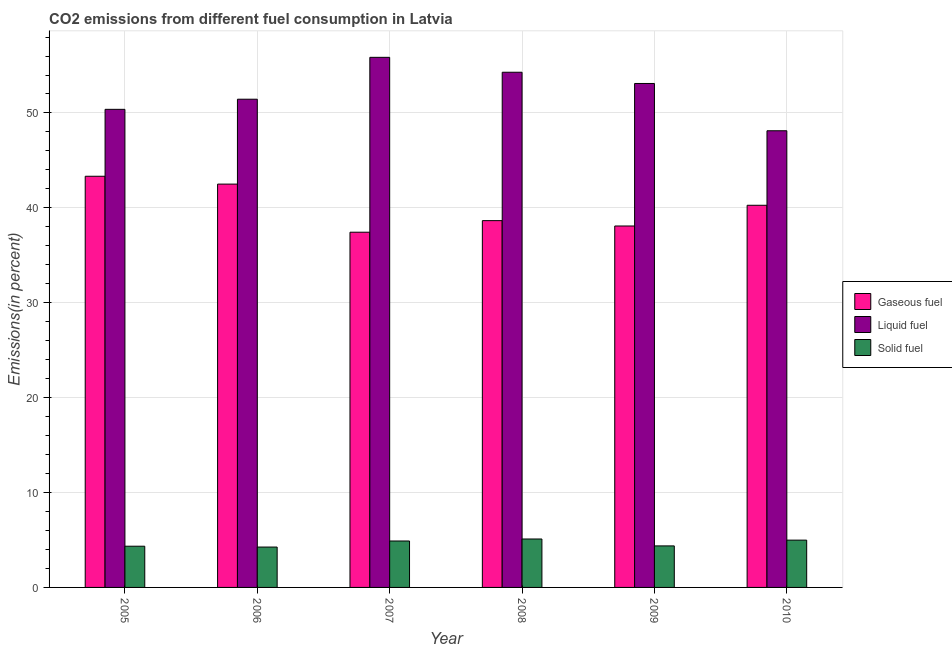How many bars are there on the 5th tick from the left?
Provide a succinct answer. 3. How many bars are there on the 4th tick from the right?
Offer a very short reply. 3. What is the percentage of gaseous fuel emission in 2010?
Keep it short and to the point. 40.27. Across all years, what is the maximum percentage of gaseous fuel emission?
Offer a very short reply. 43.33. Across all years, what is the minimum percentage of solid fuel emission?
Keep it short and to the point. 4.26. In which year was the percentage of gaseous fuel emission maximum?
Make the answer very short. 2005. In which year was the percentage of liquid fuel emission minimum?
Give a very brief answer. 2010. What is the total percentage of solid fuel emission in the graph?
Provide a short and direct response. 27.96. What is the difference between the percentage of gaseous fuel emission in 2007 and that in 2010?
Your answer should be compact. -2.84. What is the difference between the percentage of liquid fuel emission in 2007 and the percentage of gaseous fuel emission in 2005?
Your response must be concise. 5.48. What is the average percentage of gaseous fuel emission per year?
Keep it short and to the point. 40.05. In the year 2008, what is the difference between the percentage of solid fuel emission and percentage of liquid fuel emission?
Provide a short and direct response. 0. In how many years, is the percentage of solid fuel emission greater than 50 %?
Your answer should be compact. 0. What is the ratio of the percentage of gaseous fuel emission in 2005 to that in 2009?
Keep it short and to the point. 1.14. Is the difference between the percentage of solid fuel emission in 2006 and 2009 greater than the difference between the percentage of gaseous fuel emission in 2006 and 2009?
Your response must be concise. No. What is the difference between the highest and the second highest percentage of liquid fuel emission?
Give a very brief answer. 1.57. What is the difference between the highest and the lowest percentage of solid fuel emission?
Your answer should be very brief. 0.85. In how many years, is the percentage of gaseous fuel emission greater than the average percentage of gaseous fuel emission taken over all years?
Provide a succinct answer. 3. Is the sum of the percentage of gaseous fuel emission in 2005 and 2009 greater than the maximum percentage of solid fuel emission across all years?
Give a very brief answer. Yes. What does the 3rd bar from the left in 2008 represents?
Your answer should be compact. Solid fuel. What does the 1st bar from the right in 2008 represents?
Make the answer very short. Solid fuel. Is it the case that in every year, the sum of the percentage of gaseous fuel emission and percentage of liquid fuel emission is greater than the percentage of solid fuel emission?
Provide a succinct answer. Yes. Are all the bars in the graph horizontal?
Your answer should be very brief. No. How many years are there in the graph?
Your answer should be very brief. 6. Are the values on the major ticks of Y-axis written in scientific E-notation?
Your answer should be very brief. No. Does the graph contain grids?
Keep it short and to the point. Yes. Where does the legend appear in the graph?
Provide a short and direct response. Center right. How many legend labels are there?
Offer a very short reply. 3. What is the title of the graph?
Give a very brief answer. CO2 emissions from different fuel consumption in Latvia. What is the label or title of the Y-axis?
Offer a terse response. Emissions(in percent). What is the Emissions(in percent) in Gaseous fuel in 2005?
Keep it short and to the point. 43.33. What is the Emissions(in percent) in Liquid fuel in 2005?
Offer a terse response. 50.38. What is the Emissions(in percent) of Solid fuel in 2005?
Keep it short and to the point. 4.34. What is the Emissions(in percent) of Gaseous fuel in 2006?
Offer a terse response. 42.5. What is the Emissions(in percent) of Liquid fuel in 2006?
Your response must be concise. 51.45. What is the Emissions(in percent) of Solid fuel in 2006?
Make the answer very short. 4.26. What is the Emissions(in percent) of Gaseous fuel in 2007?
Ensure brevity in your answer.  37.43. What is the Emissions(in percent) of Liquid fuel in 2007?
Ensure brevity in your answer.  55.86. What is the Emissions(in percent) in Solid fuel in 2007?
Your response must be concise. 4.89. What is the Emissions(in percent) of Gaseous fuel in 2008?
Your answer should be very brief. 38.65. What is the Emissions(in percent) in Liquid fuel in 2008?
Give a very brief answer. 54.29. What is the Emissions(in percent) in Solid fuel in 2008?
Make the answer very short. 5.1. What is the Emissions(in percent) in Gaseous fuel in 2009?
Offer a very short reply. 38.09. What is the Emissions(in percent) of Liquid fuel in 2009?
Make the answer very short. 53.11. What is the Emissions(in percent) in Solid fuel in 2009?
Your answer should be compact. 4.38. What is the Emissions(in percent) of Gaseous fuel in 2010?
Provide a succinct answer. 40.27. What is the Emissions(in percent) in Liquid fuel in 2010?
Provide a succinct answer. 48.13. What is the Emissions(in percent) in Solid fuel in 2010?
Provide a short and direct response. 4.98. Across all years, what is the maximum Emissions(in percent) in Gaseous fuel?
Keep it short and to the point. 43.33. Across all years, what is the maximum Emissions(in percent) in Liquid fuel?
Your answer should be compact. 55.86. Across all years, what is the maximum Emissions(in percent) in Solid fuel?
Provide a short and direct response. 5.1. Across all years, what is the minimum Emissions(in percent) of Gaseous fuel?
Keep it short and to the point. 37.43. Across all years, what is the minimum Emissions(in percent) of Liquid fuel?
Offer a very short reply. 48.13. Across all years, what is the minimum Emissions(in percent) in Solid fuel?
Your answer should be compact. 4.26. What is the total Emissions(in percent) in Gaseous fuel in the graph?
Provide a succinct answer. 240.29. What is the total Emissions(in percent) in Liquid fuel in the graph?
Make the answer very short. 313.22. What is the total Emissions(in percent) of Solid fuel in the graph?
Your answer should be very brief. 27.96. What is the difference between the Emissions(in percent) of Gaseous fuel in 2005 and that in 2006?
Offer a terse response. 0.83. What is the difference between the Emissions(in percent) in Liquid fuel in 2005 and that in 2006?
Your response must be concise. -1.07. What is the difference between the Emissions(in percent) of Solid fuel in 2005 and that in 2006?
Offer a terse response. 0.09. What is the difference between the Emissions(in percent) in Gaseous fuel in 2005 and that in 2007?
Offer a very short reply. 5.9. What is the difference between the Emissions(in percent) of Liquid fuel in 2005 and that in 2007?
Provide a succinct answer. -5.48. What is the difference between the Emissions(in percent) of Solid fuel in 2005 and that in 2007?
Offer a very short reply. -0.55. What is the difference between the Emissions(in percent) of Gaseous fuel in 2005 and that in 2008?
Keep it short and to the point. 4.68. What is the difference between the Emissions(in percent) in Liquid fuel in 2005 and that in 2008?
Ensure brevity in your answer.  -3.91. What is the difference between the Emissions(in percent) in Solid fuel in 2005 and that in 2008?
Keep it short and to the point. -0.76. What is the difference between the Emissions(in percent) of Gaseous fuel in 2005 and that in 2009?
Keep it short and to the point. 5.24. What is the difference between the Emissions(in percent) in Liquid fuel in 2005 and that in 2009?
Ensure brevity in your answer.  -2.72. What is the difference between the Emissions(in percent) in Solid fuel in 2005 and that in 2009?
Provide a short and direct response. -0.03. What is the difference between the Emissions(in percent) in Gaseous fuel in 2005 and that in 2010?
Provide a short and direct response. 3.06. What is the difference between the Emissions(in percent) in Liquid fuel in 2005 and that in 2010?
Ensure brevity in your answer.  2.26. What is the difference between the Emissions(in percent) of Solid fuel in 2005 and that in 2010?
Your answer should be very brief. -0.64. What is the difference between the Emissions(in percent) in Gaseous fuel in 2006 and that in 2007?
Make the answer very short. 5.07. What is the difference between the Emissions(in percent) in Liquid fuel in 2006 and that in 2007?
Your response must be concise. -4.41. What is the difference between the Emissions(in percent) of Solid fuel in 2006 and that in 2007?
Ensure brevity in your answer.  -0.64. What is the difference between the Emissions(in percent) of Gaseous fuel in 2006 and that in 2008?
Make the answer very short. 3.85. What is the difference between the Emissions(in percent) in Liquid fuel in 2006 and that in 2008?
Offer a terse response. -2.84. What is the difference between the Emissions(in percent) of Solid fuel in 2006 and that in 2008?
Your response must be concise. -0.85. What is the difference between the Emissions(in percent) in Gaseous fuel in 2006 and that in 2009?
Provide a short and direct response. 4.41. What is the difference between the Emissions(in percent) in Liquid fuel in 2006 and that in 2009?
Offer a very short reply. -1.66. What is the difference between the Emissions(in percent) in Solid fuel in 2006 and that in 2009?
Your answer should be very brief. -0.12. What is the difference between the Emissions(in percent) in Gaseous fuel in 2006 and that in 2010?
Give a very brief answer. 2.23. What is the difference between the Emissions(in percent) of Liquid fuel in 2006 and that in 2010?
Provide a short and direct response. 3.33. What is the difference between the Emissions(in percent) of Solid fuel in 2006 and that in 2010?
Ensure brevity in your answer.  -0.73. What is the difference between the Emissions(in percent) of Gaseous fuel in 2007 and that in 2008?
Provide a succinct answer. -1.22. What is the difference between the Emissions(in percent) of Liquid fuel in 2007 and that in 2008?
Your answer should be very brief. 1.57. What is the difference between the Emissions(in percent) in Solid fuel in 2007 and that in 2008?
Your answer should be very brief. -0.21. What is the difference between the Emissions(in percent) of Gaseous fuel in 2007 and that in 2009?
Make the answer very short. -0.66. What is the difference between the Emissions(in percent) in Liquid fuel in 2007 and that in 2009?
Offer a very short reply. 2.76. What is the difference between the Emissions(in percent) of Solid fuel in 2007 and that in 2009?
Give a very brief answer. 0.52. What is the difference between the Emissions(in percent) of Gaseous fuel in 2007 and that in 2010?
Make the answer very short. -2.84. What is the difference between the Emissions(in percent) in Liquid fuel in 2007 and that in 2010?
Provide a succinct answer. 7.74. What is the difference between the Emissions(in percent) in Solid fuel in 2007 and that in 2010?
Your answer should be very brief. -0.09. What is the difference between the Emissions(in percent) in Gaseous fuel in 2008 and that in 2009?
Provide a succinct answer. 0.56. What is the difference between the Emissions(in percent) of Liquid fuel in 2008 and that in 2009?
Ensure brevity in your answer.  1.18. What is the difference between the Emissions(in percent) in Solid fuel in 2008 and that in 2009?
Provide a short and direct response. 0.73. What is the difference between the Emissions(in percent) in Gaseous fuel in 2008 and that in 2010?
Ensure brevity in your answer.  -1.62. What is the difference between the Emissions(in percent) in Liquid fuel in 2008 and that in 2010?
Provide a short and direct response. 6.17. What is the difference between the Emissions(in percent) in Solid fuel in 2008 and that in 2010?
Ensure brevity in your answer.  0.12. What is the difference between the Emissions(in percent) of Gaseous fuel in 2009 and that in 2010?
Keep it short and to the point. -2.18. What is the difference between the Emissions(in percent) of Liquid fuel in 2009 and that in 2010?
Give a very brief answer. 4.98. What is the difference between the Emissions(in percent) in Solid fuel in 2009 and that in 2010?
Provide a short and direct response. -0.61. What is the difference between the Emissions(in percent) in Gaseous fuel in 2005 and the Emissions(in percent) in Liquid fuel in 2006?
Ensure brevity in your answer.  -8.12. What is the difference between the Emissions(in percent) of Gaseous fuel in 2005 and the Emissions(in percent) of Solid fuel in 2006?
Your response must be concise. 39.08. What is the difference between the Emissions(in percent) in Liquid fuel in 2005 and the Emissions(in percent) in Solid fuel in 2006?
Offer a very short reply. 46.13. What is the difference between the Emissions(in percent) in Gaseous fuel in 2005 and the Emissions(in percent) in Liquid fuel in 2007?
Offer a very short reply. -12.53. What is the difference between the Emissions(in percent) in Gaseous fuel in 2005 and the Emissions(in percent) in Solid fuel in 2007?
Make the answer very short. 38.44. What is the difference between the Emissions(in percent) in Liquid fuel in 2005 and the Emissions(in percent) in Solid fuel in 2007?
Provide a succinct answer. 45.49. What is the difference between the Emissions(in percent) in Gaseous fuel in 2005 and the Emissions(in percent) in Liquid fuel in 2008?
Offer a terse response. -10.96. What is the difference between the Emissions(in percent) in Gaseous fuel in 2005 and the Emissions(in percent) in Solid fuel in 2008?
Offer a terse response. 38.23. What is the difference between the Emissions(in percent) of Liquid fuel in 2005 and the Emissions(in percent) of Solid fuel in 2008?
Your response must be concise. 45.28. What is the difference between the Emissions(in percent) in Gaseous fuel in 2005 and the Emissions(in percent) in Liquid fuel in 2009?
Your answer should be very brief. -9.78. What is the difference between the Emissions(in percent) of Gaseous fuel in 2005 and the Emissions(in percent) of Solid fuel in 2009?
Your answer should be very brief. 38.96. What is the difference between the Emissions(in percent) of Liquid fuel in 2005 and the Emissions(in percent) of Solid fuel in 2009?
Give a very brief answer. 46.01. What is the difference between the Emissions(in percent) of Gaseous fuel in 2005 and the Emissions(in percent) of Liquid fuel in 2010?
Ensure brevity in your answer.  -4.79. What is the difference between the Emissions(in percent) of Gaseous fuel in 2005 and the Emissions(in percent) of Solid fuel in 2010?
Offer a very short reply. 38.35. What is the difference between the Emissions(in percent) of Liquid fuel in 2005 and the Emissions(in percent) of Solid fuel in 2010?
Offer a terse response. 45.4. What is the difference between the Emissions(in percent) in Gaseous fuel in 2006 and the Emissions(in percent) in Liquid fuel in 2007?
Your response must be concise. -13.36. What is the difference between the Emissions(in percent) of Gaseous fuel in 2006 and the Emissions(in percent) of Solid fuel in 2007?
Your answer should be very brief. 37.61. What is the difference between the Emissions(in percent) in Liquid fuel in 2006 and the Emissions(in percent) in Solid fuel in 2007?
Make the answer very short. 46.56. What is the difference between the Emissions(in percent) of Gaseous fuel in 2006 and the Emissions(in percent) of Liquid fuel in 2008?
Offer a very short reply. -11.79. What is the difference between the Emissions(in percent) of Gaseous fuel in 2006 and the Emissions(in percent) of Solid fuel in 2008?
Make the answer very short. 37.4. What is the difference between the Emissions(in percent) of Liquid fuel in 2006 and the Emissions(in percent) of Solid fuel in 2008?
Give a very brief answer. 46.35. What is the difference between the Emissions(in percent) of Gaseous fuel in 2006 and the Emissions(in percent) of Liquid fuel in 2009?
Keep it short and to the point. -10.6. What is the difference between the Emissions(in percent) in Gaseous fuel in 2006 and the Emissions(in percent) in Solid fuel in 2009?
Provide a short and direct response. 38.13. What is the difference between the Emissions(in percent) in Liquid fuel in 2006 and the Emissions(in percent) in Solid fuel in 2009?
Give a very brief answer. 47.07. What is the difference between the Emissions(in percent) in Gaseous fuel in 2006 and the Emissions(in percent) in Liquid fuel in 2010?
Give a very brief answer. -5.62. What is the difference between the Emissions(in percent) in Gaseous fuel in 2006 and the Emissions(in percent) in Solid fuel in 2010?
Offer a terse response. 37.52. What is the difference between the Emissions(in percent) in Liquid fuel in 2006 and the Emissions(in percent) in Solid fuel in 2010?
Ensure brevity in your answer.  46.47. What is the difference between the Emissions(in percent) in Gaseous fuel in 2007 and the Emissions(in percent) in Liquid fuel in 2008?
Ensure brevity in your answer.  -16.86. What is the difference between the Emissions(in percent) of Gaseous fuel in 2007 and the Emissions(in percent) of Solid fuel in 2008?
Provide a succinct answer. 32.33. What is the difference between the Emissions(in percent) in Liquid fuel in 2007 and the Emissions(in percent) in Solid fuel in 2008?
Ensure brevity in your answer.  50.76. What is the difference between the Emissions(in percent) of Gaseous fuel in 2007 and the Emissions(in percent) of Liquid fuel in 2009?
Your answer should be very brief. -15.67. What is the difference between the Emissions(in percent) in Gaseous fuel in 2007 and the Emissions(in percent) in Solid fuel in 2009?
Make the answer very short. 33.06. What is the difference between the Emissions(in percent) of Liquid fuel in 2007 and the Emissions(in percent) of Solid fuel in 2009?
Keep it short and to the point. 51.49. What is the difference between the Emissions(in percent) of Gaseous fuel in 2007 and the Emissions(in percent) of Liquid fuel in 2010?
Provide a short and direct response. -10.69. What is the difference between the Emissions(in percent) of Gaseous fuel in 2007 and the Emissions(in percent) of Solid fuel in 2010?
Provide a short and direct response. 32.45. What is the difference between the Emissions(in percent) of Liquid fuel in 2007 and the Emissions(in percent) of Solid fuel in 2010?
Make the answer very short. 50.88. What is the difference between the Emissions(in percent) of Gaseous fuel in 2008 and the Emissions(in percent) of Liquid fuel in 2009?
Your response must be concise. -14.45. What is the difference between the Emissions(in percent) in Gaseous fuel in 2008 and the Emissions(in percent) in Solid fuel in 2009?
Offer a very short reply. 34.28. What is the difference between the Emissions(in percent) in Liquid fuel in 2008 and the Emissions(in percent) in Solid fuel in 2009?
Ensure brevity in your answer.  49.92. What is the difference between the Emissions(in percent) of Gaseous fuel in 2008 and the Emissions(in percent) of Liquid fuel in 2010?
Provide a succinct answer. -9.47. What is the difference between the Emissions(in percent) in Gaseous fuel in 2008 and the Emissions(in percent) in Solid fuel in 2010?
Your response must be concise. 33.67. What is the difference between the Emissions(in percent) of Liquid fuel in 2008 and the Emissions(in percent) of Solid fuel in 2010?
Your answer should be compact. 49.31. What is the difference between the Emissions(in percent) in Gaseous fuel in 2009 and the Emissions(in percent) in Liquid fuel in 2010?
Offer a terse response. -10.03. What is the difference between the Emissions(in percent) in Gaseous fuel in 2009 and the Emissions(in percent) in Solid fuel in 2010?
Your answer should be very brief. 33.11. What is the difference between the Emissions(in percent) of Liquid fuel in 2009 and the Emissions(in percent) of Solid fuel in 2010?
Ensure brevity in your answer.  48.12. What is the average Emissions(in percent) of Gaseous fuel per year?
Your response must be concise. 40.05. What is the average Emissions(in percent) of Liquid fuel per year?
Your answer should be very brief. 52.2. What is the average Emissions(in percent) in Solid fuel per year?
Your answer should be compact. 4.66. In the year 2005, what is the difference between the Emissions(in percent) of Gaseous fuel and Emissions(in percent) of Liquid fuel?
Provide a succinct answer. -7.05. In the year 2005, what is the difference between the Emissions(in percent) of Gaseous fuel and Emissions(in percent) of Solid fuel?
Offer a terse response. 38.99. In the year 2005, what is the difference between the Emissions(in percent) of Liquid fuel and Emissions(in percent) of Solid fuel?
Offer a very short reply. 46.04. In the year 2006, what is the difference between the Emissions(in percent) in Gaseous fuel and Emissions(in percent) in Liquid fuel?
Keep it short and to the point. -8.95. In the year 2006, what is the difference between the Emissions(in percent) of Gaseous fuel and Emissions(in percent) of Solid fuel?
Offer a terse response. 38.25. In the year 2006, what is the difference between the Emissions(in percent) of Liquid fuel and Emissions(in percent) of Solid fuel?
Your answer should be very brief. 47.2. In the year 2007, what is the difference between the Emissions(in percent) in Gaseous fuel and Emissions(in percent) in Liquid fuel?
Provide a succinct answer. -18.43. In the year 2007, what is the difference between the Emissions(in percent) of Gaseous fuel and Emissions(in percent) of Solid fuel?
Your answer should be compact. 32.54. In the year 2007, what is the difference between the Emissions(in percent) of Liquid fuel and Emissions(in percent) of Solid fuel?
Keep it short and to the point. 50.97. In the year 2008, what is the difference between the Emissions(in percent) in Gaseous fuel and Emissions(in percent) in Liquid fuel?
Keep it short and to the point. -15.64. In the year 2008, what is the difference between the Emissions(in percent) in Gaseous fuel and Emissions(in percent) in Solid fuel?
Offer a terse response. 33.55. In the year 2008, what is the difference between the Emissions(in percent) of Liquid fuel and Emissions(in percent) of Solid fuel?
Your answer should be very brief. 49.19. In the year 2009, what is the difference between the Emissions(in percent) of Gaseous fuel and Emissions(in percent) of Liquid fuel?
Your answer should be compact. -15.02. In the year 2009, what is the difference between the Emissions(in percent) of Gaseous fuel and Emissions(in percent) of Solid fuel?
Offer a terse response. 33.71. In the year 2009, what is the difference between the Emissions(in percent) of Liquid fuel and Emissions(in percent) of Solid fuel?
Your response must be concise. 48.73. In the year 2010, what is the difference between the Emissions(in percent) of Gaseous fuel and Emissions(in percent) of Liquid fuel?
Keep it short and to the point. -7.85. In the year 2010, what is the difference between the Emissions(in percent) in Gaseous fuel and Emissions(in percent) in Solid fuel?
Your answer should be compact. 35.29. In the year 2010, what is the difference between the Emissions(in percent) of Liquid fuel and Emissions(in percent) of Solid fuel?
Your answer should be very brief. 43.14. What is the ratio of the Emissions(in percent) in Gaseous fuel in 2005 to that in 2006?
Your answer should be compact. 1.02. What is the ratio of the Emissions(in percent) in Liquid fuel in 2005 to that in 2006?
Offer a very short reply. 0.98. What is the ratio of the Emissions(in percent) of Solid fuel in 2005 to that in 2006?
Make the answer very short. 1.02. What is the ratio of the Emissions(in percent) of Gaseous fuel in 2005 to that in 2007?
Keep it short and to the point. 1.16. What is the ratio of the Emissions(in percent) in Liquid fuel in 2005 to that in 2007?
Make the answer very short. 0.9. What is the ratio of the Emissions(in percent) of Solid fuel in 2005 to that in 2007?
Your response must be concise. 0.89. What is the ratio of the Emissions(in percent) of Gaseous fuel in 2005 to that in 2008?
Your response must be concise. 1.12. What is the ratio of the Emissions(in percent) of Liquid fuel in 2005 to that in 2008?
Ensure brevity in your answer.  0.93. What is the ratio of the Emissions(in percent) of Solid fuel in 2005 to that in 2008?
Ensure brevity in your answer.  0.85. What is the ratio of the Emissions(in percent) in Gaseous fuel in 2005 to that in 2009?
Give a very brief answer. 1.14. What is the ratio of the Emissions(in percent) of Liquid fuel in 2005 to that in 2009?
Give a very brief answer. 0.95. What is the ratio of the Emissions(in percent) in Gaseous fuel in 2005 to that in 2010?
Your answer should be compact. 1.08. What is the ratio of the Emissions(in percent) of Liquid fuel in 2005 to that in 2010?
Your answer should be very brief. 1.05. What is the ratio of the Emissions(in percent) in Solid fuel in 2005 to that in 2010?
Provide a short and direct response. 0.87. What is the ratio of the Emissions(in percent) of Gaseous fuel in 2006 to that in 2007?
Your response must be concise. 1.14. What is the ratio of the Emissions(in percent) in Liquid fuel in 2006 to that in 2007?
Offer a terse response. 0.92. What is the ratio of the Emissions(in percent) of Solid fuel in 2006 to that in 2007?
Provide a succinct answer. 0.87. What is the ratio of the Emissions(in percent) of Gaseous fuel in 2006 to that in 2008?
Provide a succinct answer. 1.1. What is the ratio of the Emissions(in percent) in Liquid fuel in 2006 to that in 2008?
Your response must be concise. 0.95. What is the ratio of the Emissions(in percent) in Solid fuel in 2006 to that in 2008?
Your response must be concise. 0.83. What is the ratio of the Emissions(in percent) of Gaseous fuel in 2006 to that in 2009?
Keep it short and to the point. 1.12. What is the ratio of the Emissions(in percent) of Liquid fuel in 2006 to that in 2009?
Your response must be concise. 0.97. What is the ratio of the Emissions(in percent) of Solid fuel in 2006 to that in 2009?
Ensure brevity in your answer.  0.97. What is the ratio of the Emissions(in percent) in Gaseous fuel in 2006 to that in 2010?
Your answer should be very brief. 1.06. What is the ratio of the Emissions(in percent) of Liquid fuel in 2006 to that in 2010?
Your answer should be compact. 1.07. What is the ratio of the Emissions(in percent) in Solid fuel in 2006 to that in 2010?
Your answer should be very brief. 0.85. What is the ratio of the Emissions(in percent) of Gaseous fuel in 2007 to that in 2008?
Keep it short and to the point. 0.97. What is the ratio of the Emissions(in percent) of Solid fuel in 2007 to that in 2008?
Your answer should be compact. 0.96. What is the ratio of the Emissions(in percent) of Gaseous fuel in 2007 to that in 2009?
Your answer should be compact. 0.98. What is the ratio of the Emissions(in percent) of Liquid fuel in 2007 to that in 2009?
Your answer should be compact. 1.05. What is the ratio of the Emissions(in percent) in Solid fuel in 2007 to that in 2009?
Your answer should be compact. 1.12. What is the ratio of the Emissions(in percent) of Gaseous fuel in 2007 to that in 2010?
Offer a very short reply. 0.93. What is the ratio of the Emissions(in percent) of Liquid fuel in 2007 to that in 2010?
Offer a very short reply. 1.16. What is the ratio of the Emissions(in percent) of Solid fuel in 2007 to that in 2010?
Make the answer very short. 0.98. What is the ratio of the Emissions(in percent) in Gaseous fuel in 2008 to that in 2009?
Provide a succinct answer. 1.01. What is the ratio of the Emissions(in percent) in Liquid fuel in 2008 to that in 2009?
Provide a succinct answer. 1.02. What is the ratio of the Emissions(in percent) in Solid fuel in 2008 to that in 2009?
Your answer should be compact. 1.17. What is the ratio of the Emissions(in percent) of Gaseous fuel in 2008 to that in 2010?
Make the answer very short. 0.96. What is the ratio of the Emissions(in percent) of Liquid fuel in 2008 to that in 2010?
Your answer should be compact. 1.13. What is the ratio of the Emissions(in percent) in Gaseous fuel in 2009 to that in 2010?
Make the answer very short. 0.95. What is the ratio of the Emissions(in percent) of Liquid fuel in 2009 to that in 2010?
Your response must be concise. 1.1. What is the ratio of the Emissions(in percent) in Solid fuel in 2009 to that in 2010?
Make the answer very short. 0.88. What is the difference between the highest and the second highest Emissions(in percent) of Gaseous fuel?
Provide a succinct answer. 0.83. What is the difference between the highest and the second highest Emissions(in percent) in Liquid fuel?
Make the answer very short. 1.57. What is the difference between the highest and the second highest Emissions(in percent) of Solid fuel?
Your answer should be compact. 0.12. What is the difference between the highest and the lowest Emissions(in percent) of Gaseous fuel?
Your response must be concise. 5.9. What is the difference between the highest and the lowest Emissions(in percent) of Liquid fuel?
Provide a succinct answer. 7.74. What is the difference between the highest and the lowest Emissions(in percent) of Solid fuel?
Give a very brief answer. 0.85. 